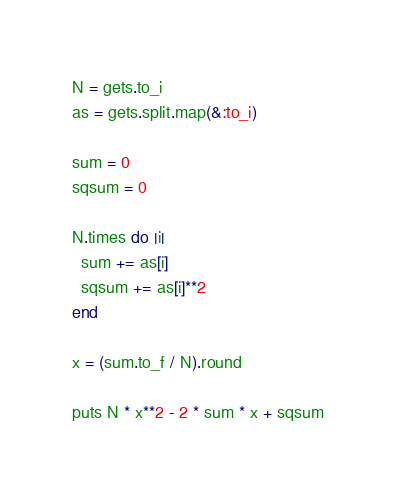Convert code to text. <code><loc_0><loc_0><loc_500><loc_500><_Ruby_>N = gets.to_i
as = gets.split.map(&:to_i)

sum = 0
sqsum = 0

N.times do |i|
  sum += as[i]
  sqsum += as[i]**2
end

x = (sum.to_f / N).round

puts N * x**2 - 2 * sum * x + sqsum
</code> 